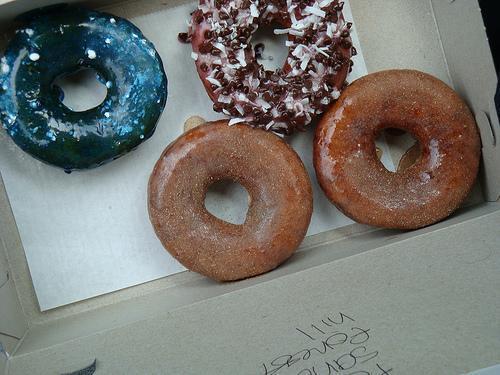How many donuts are there?
Give a very brief answer. 4. How many glazed donuts are there?
Give a very brief answer. 2. How many doughnuts are pictured?
Give a very brief answer. 4. 